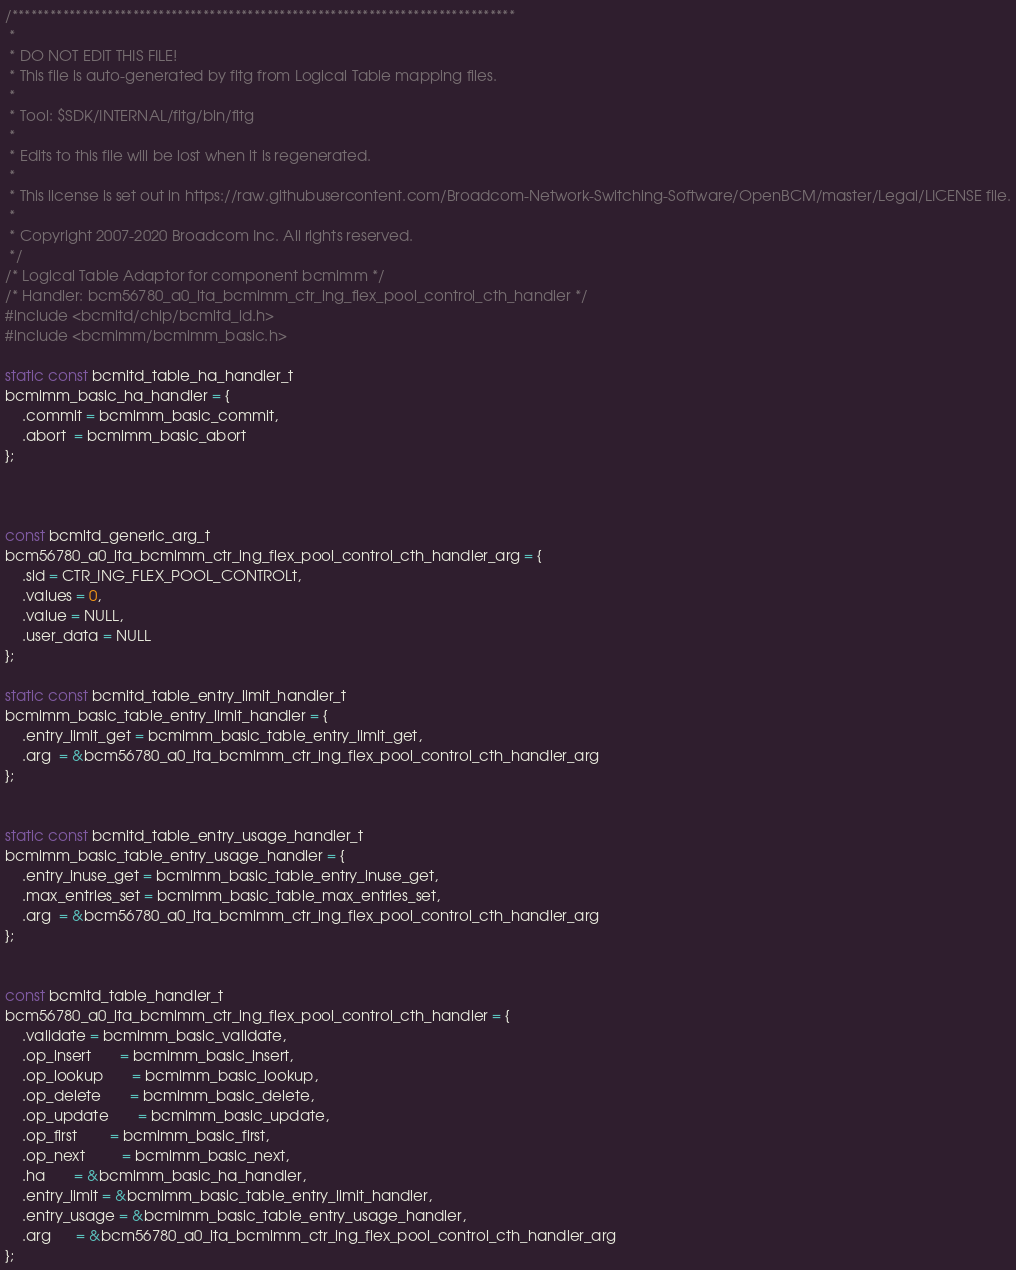<code> <loc_0><loc_0><loc_500><loc_500><_C_>/*******************************************************************************
 *
 * DO NOT EDIT THIS FILE!
 * This file is auto-generated by fltg from Logical Table mapping files.
 *
 * Tool: $SDK/INTERNAL/fltg/bin/fltg
 *
 * Edits to this file will be lost when it is regenerated.
 *
 * This license is set out in https://raw.githubusercontent.com/Broadcom-Network-Switching-Software/OpenBCM/master/Legal/LICENSE file.
 * 
 * Copyright 2007-2020 Broadcom Inc. All rights reserved.
 */
/* Logical Table Adaptor for component bcmimm */
/* Handler: bcm56780_a0_lta_bcmimm_ctr_ing_flex_pool_control_cth_handler */
#include <bcmltd/chip/bcmltd_id.h>
#include <bcmimm/bcmimm_basic.h>

static const bcmltd_table_ha_handler_t
bcmimm_basic_ha_handler = {
    .commit = bcmimm_basic_commit,
    .abort  = bcmimm_basic_abort
};



const bcmltd_generic_arg_t
bcm56780_a0_lta_bcmimm_ctr_ing_flex_pool_control_cth_handler_arg = {
    .sid = CTR_ING_FLEX_POOL_CONTROLt,
    .values = 0,
    .value = NULL,
    .user_data = NULL
};

static const bcmltd_table_entry_limit_handler_t
bcmimm_basic_table_entry_limit_handler = {
    .entry_limit_get = bcmimm_basic_table_entry_limit_get,
    .arg  = &bcm56780_a0_lta_bcmimm_ctr_ing_flex_pool_control_cth_handler_arg
};


static const bcmltd_table_entry_usage_handler_t
bcmimm_basic_table_entry_usage_handler = {
    .entry_inuse_get = bcmimm_basic_table_entry_inuse_get,
    .max_entries_set = bcmimm_basic_table_max_entries_set,
    .arg  = &bcm56780_a0_lta_bcmimm_ctr_ing_flex_pool_control_cth_handler_arg
};


const bcmltd_table_handler_t
bcm56780_a0_lta_bcmimm_ctr_ing_flex_pool_control_cth_handler = {
    .validate = bcmimm_basic_validate,
    .op_insert       = bcmimm_basic_insert,
    .op_lookup       = bcmimm_basic_lookup,
    .op_delete       = bcmimm_basic_delete,
    .op_update       = bcmimm_basic_update,
    .op_first        = bcmimm_basic_first,
    .op_next         = bcmimm_basic_next,
    .ha       = &bcmimm_basic_ha_handler,
    .entry_limit = &bcmimm_basic_table_entry_limit_handler,
    .entry_usage = &bcmimm_basic_table_entry_usage_handler,
    .arg      = &bcm56780_a0_lta_bcmimm_ctr_ing_flex_pool_control_cth_handler_arg
};

</code> 